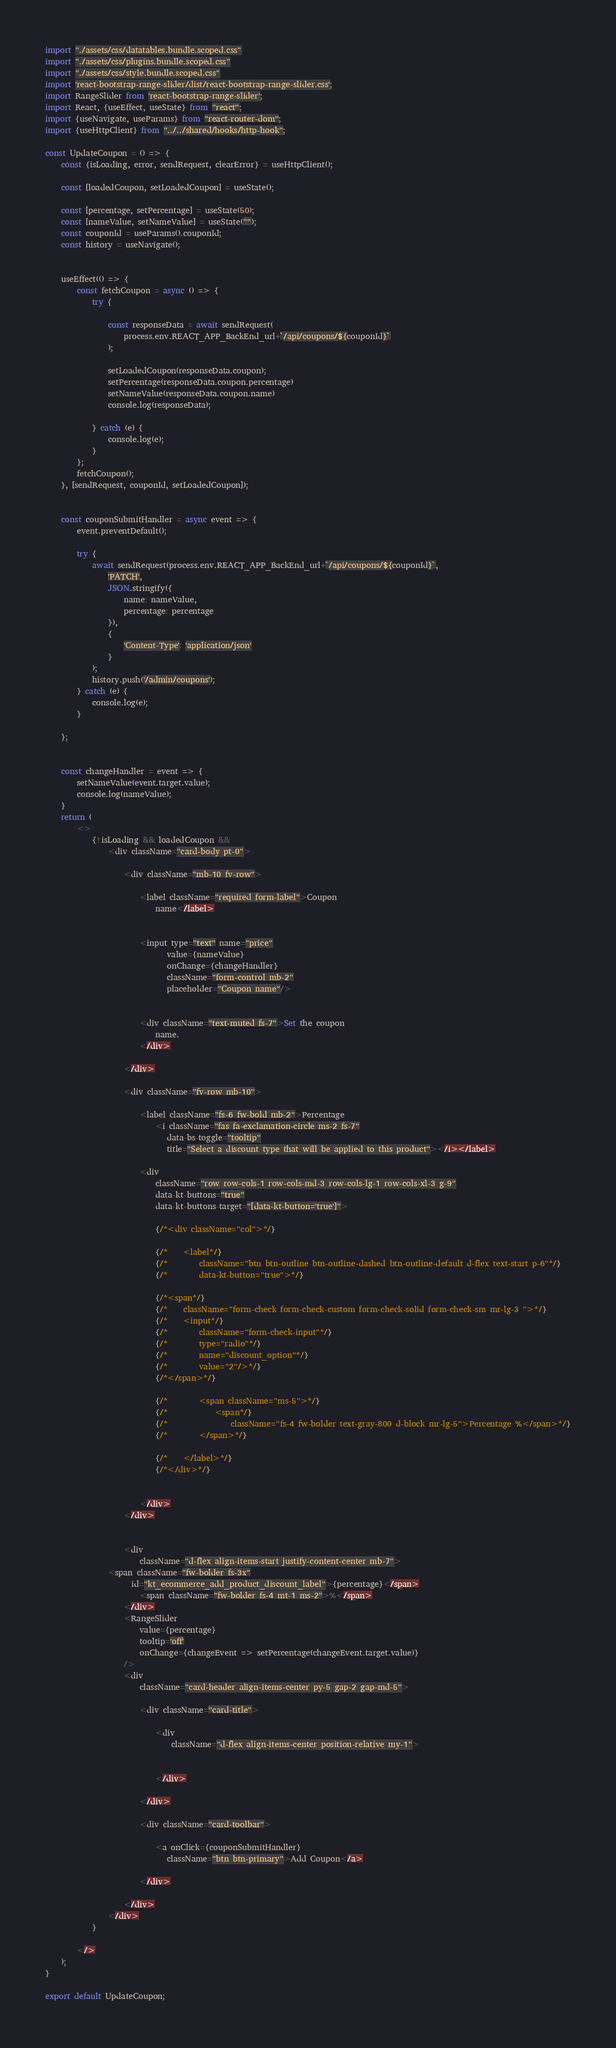<code> <loc_0><loc_0><loc_500><loc_500><_JavaScript_>import "./assets/css/datatables.bundle.scoped.css"
import "./assets/css/plugins.bundle.scoped.css"
import "./assets/css/style.bundle.scoped.css"
import 'react-bootstrap-range-slider/dist/react-bootstrap-range-slider.css';
import RangeSlider from 'react-bootstrap-range-slider';
import React, {useEffect, useState} from "react";
import {useNavigate, useParams} from "react-router-dom";
import {useHttpClient} from "../../shared/hooks/http-hook";

const UpdateCoupon = () => {
    const {isLoading, error, sendRequest, clearError} = useHttpClient();

    const [loadedCoupon, setLoadedCoupon] = useState();

    const [percentage, setPercentage] = useState(50);
    const [nameValue, setNameValue] = useState("");
    const couponId = useParams().couponId;
    const history = useNavigate();


    useEffect(() => {
        const fetchCoupon = async () => {
            try {

                const responseData = await sendRequest(
                    process.env.REACT_APP_BackEnd_url+`/api/coupons/${couponId}`
                );

                setLoadedCoupon(responseData.coupon);
                setPercentage(responseData.coupon.percentage)
                setNameValue(responseData.coupon.name)
                console.log(responseData);

            } catch (e) {
                console.log(e);
            }
        };
        fetchCoupon();
    }, [sendRequest, couponId, setLoadedCoupon]);


    const couponSubmitHandler = async event => {
        event.preventDefault();

        try {
            await sendRequest(process.env.REACT_APP_BackEnd_url+`/api/coupons/${couponId}`,
                'PATCH',
                JSON.stringify({
                    name: nameValue,
                    percentage: percentage
                }),
                {
                    'Content-Type': 'application/json'
                }
            );
            history.push('/admin/coupons');
        } catch (e) {
            console.log(e);
        }

    };


    const changeHandler = event => {
        setNameValue(event.target.value);
        console.log(nameValue);
    }
    return (
        <>
            {!isLoading && loadedCoupon &&
                <div className="card-body pt-0">

                    <div className="mb-10 fv-row">

                        <label className="required form-label">Coupon
                            name</label>


                        <input type="text" name="price"
                               value={nameValue}
                               onChange={changeHandler}
                               className="form-control mb-2"
                               placeholder="Coupon name"/>


                        <div className="text-muted fs-7">Set the coupon
                            name.
                        </div>

                    </div>

                    <div className="fv-row mb-10">

                        <label className="fs-6 fw-bold mb-2">Percentage
                            <i className="fas fa-exclamation-circle ms-2 fs-7"
                               data-bs-toggle="tooltip"
                               title="Select a discount type that will be applied to this product"></i></label>

                        <div
                            className="row row-cols-1 row-cols-md-3 row-cols-lg-1 row-cols-xl-3 g-9"
                            data-kt-buttons="true"
                            data-kt-buttons-target="[data-kt-button='true']">

                            {/*<div className="col">*/}

                            {/*    <label*/}
                            {/*        className="btn btn-outline btn-outline-dashed btn-outline-default d-flex text-start p-6"*/}
                            {/*        data-kt-button="true">*/}

                            {/*<span*/}
                            {/*    className="form-check form-check-custom form-check-solid form-check-sm mr-lg-3 ">*/}
                            {/*    <input*/}
                            {/*        className="form-check-input"*/}
                            {/*        type="radio"*/}
                            {/*        name="discount_option"*/}
                            {/*        value="2"/>*/}
                            {/*</span>*/}

                            {/*        <span className="ms-5">*/}
                            {/*            <span*/}
                            {/*                className="fs-4 fw-bolder text-gray-800 d-block mr-lg-5">Percentage %</span>*/}
                            {/*        </span>*/}

                            {/*    </label>*/}
                            {/*</div>*/}


                        </div>
                    </div>


                    <div
                        className="d-flex align-items-start justify-content-center mb-7">
                <span className="fw-bolder fs-3x"
                      id="kt_ecommerce_add_product_discount_label">{percentage}</span>
                        <span className="fw-bolder fs-4 mt-1 ms-2">%</span>
                    </div>
                    <RangeSlider
                        value={percentage}
                        tooltip='off'
                        onChange={changeEvent => setPercentage(changeEvent.target.value)}
                    />
                    <div
                        className="card-header align-items-center py-5 gap-2 gap-md-5">

                        <div className="card-title">

                            <div
                                className="d-flex align-items-center position-relative my-1">


                            </div>

                        </div>

                        <div className="card-toolbar">

                            <a onClick={couponSubmitHandler}
                               className="btn btn-primary">Add Coupon</a>

                        </div>

                    </div>
                </div>
            }

        </>
    );
}

export default UpdateCoupon;</code> 